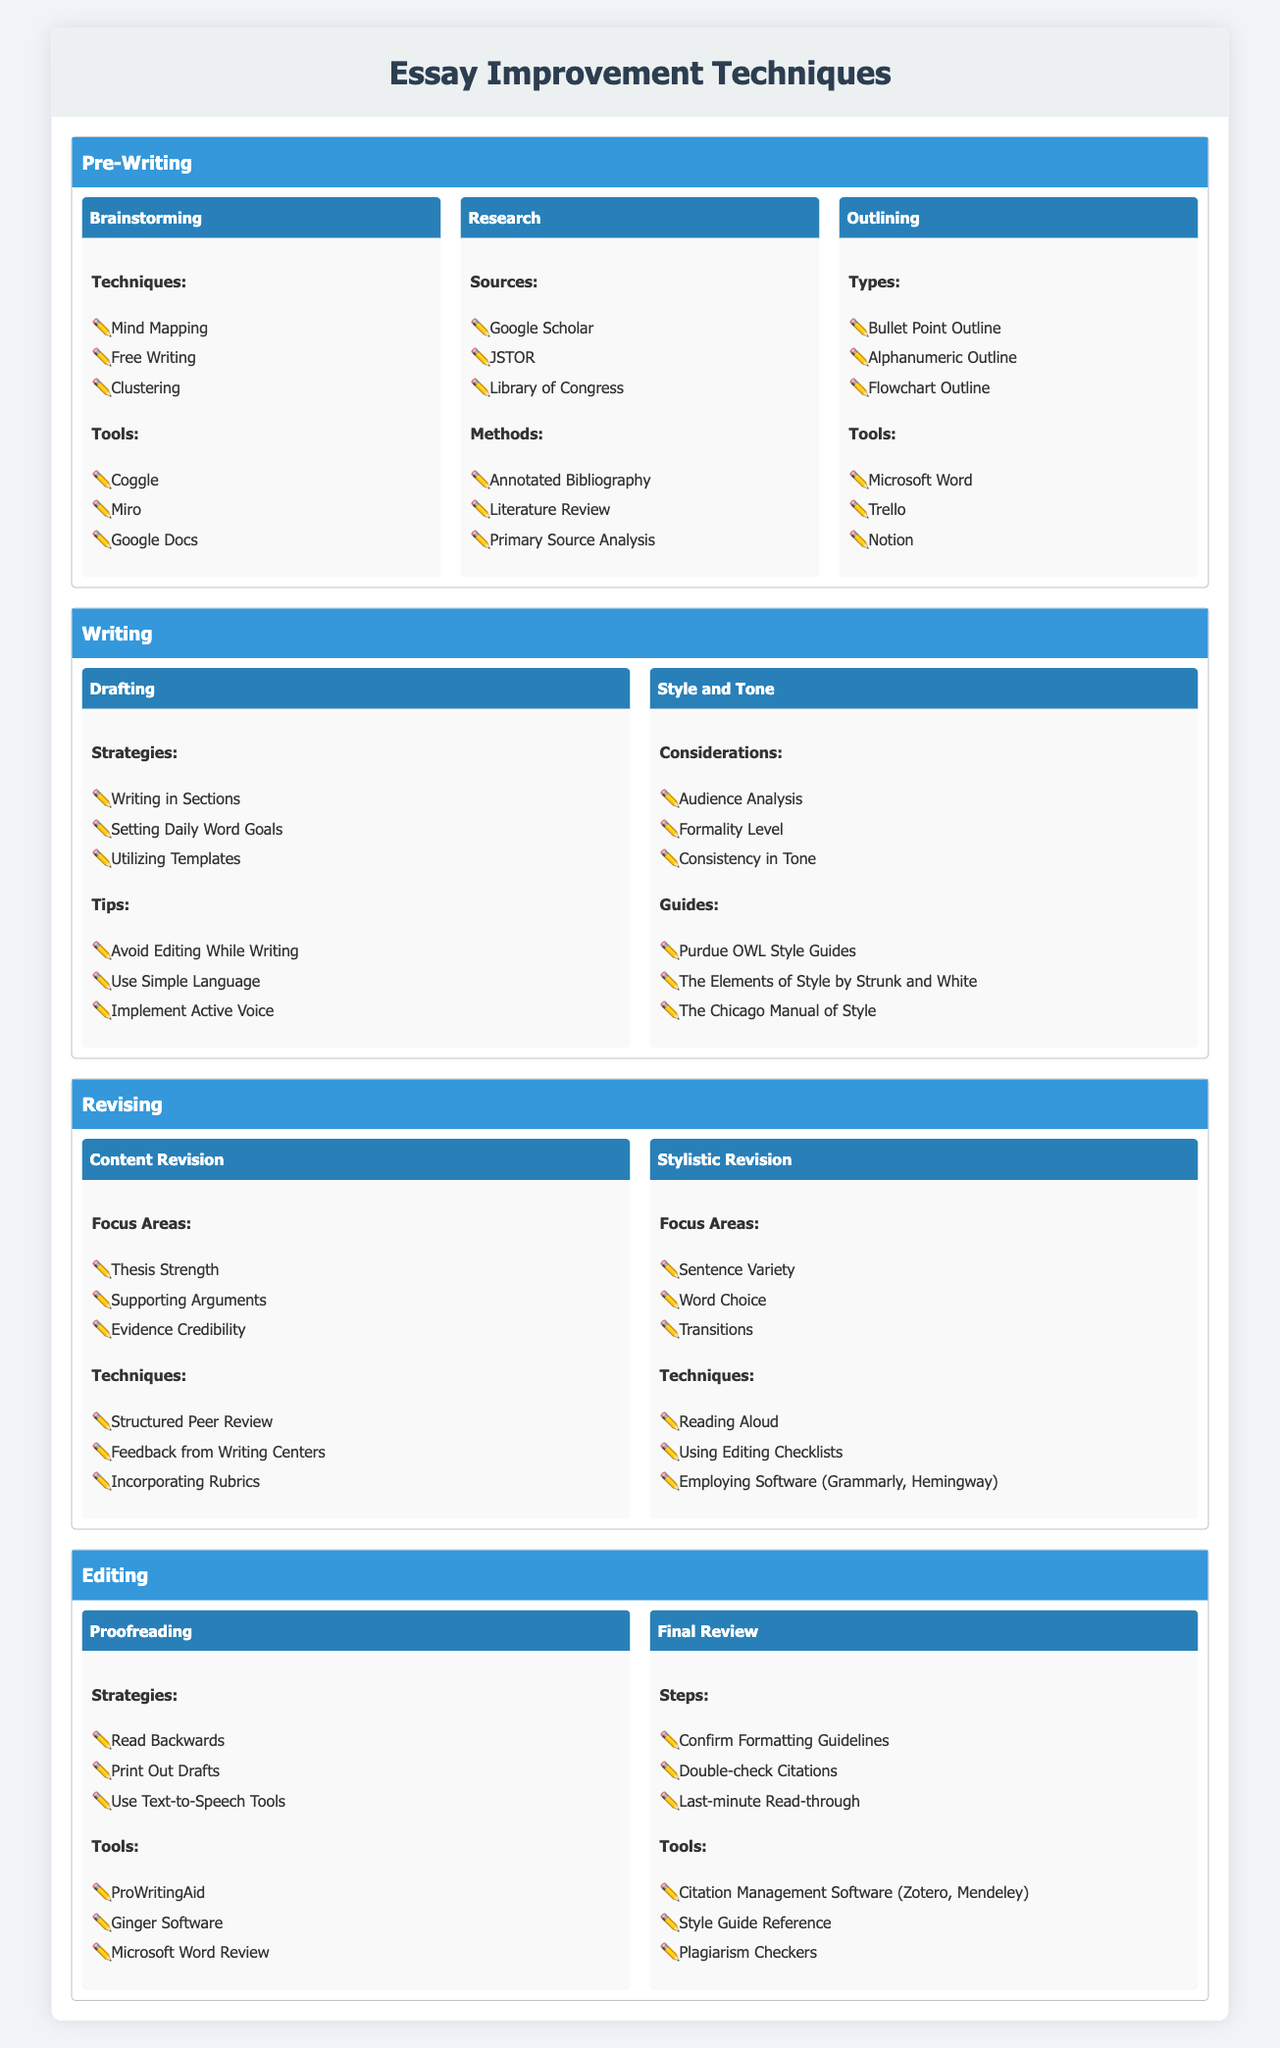What are the techniques listed under brainstorming in the pre-writing stage? The table lists three techniques under brainstorming: Mind Mapping, Free Writing, and Clustering. These are presented under the category of Brainstorming in the Pre-Writing section.
Answer: Mind Mapping, Free Writing, Clustering Which tools can be used for outlining? The tools for outlining are mentioned as Microsoft Word, Trello, and Notion, found in the Outlining subcategory of the Pre-Writing stage.
Answer: Microsoft Word, Trello, Notion Are there any considerations for style and tone in the writing stage? Yes, the table includes considerations for style and tone: Audience Analysis, Formality Level, and Consistency in Tone, found in the Style and Tone category under the Writing stage.
Answer: Yes How many strategies are listed under proofreading and what are they? There are three strategies for proofreading: Read Backwards, Print Out Drafts, and Use Text-to-Speech Tools. This information is gathered from the Proofreading subcategory in the Editing stage.
Answer: 3 strategies: Read Backwards, Print Out Drafts, Use Text-to-Speech Tools If a writer aims to enhance the strength of their thesis and improve supporting arguments, which revision focus areas should they consider? The writer should focus on "Thesis Strength" and "Supporting Arguments" as these are explicitly listed as focus areas under Content Revision in the Revising stage of the table.
Answer: Thesis Strength, Supporting Arguments What types of outlines are available and how many are listed? The table outlines three types of outlines: Bullet Point Outline, Alphanumeric Outline, and Flowchart Outline. By counting the listed types in the Outlining category, we find there are three different types.
Answer: 3 types: Bullet Point Outline, Alphanumeric Outline, Flowchart Outline Are there any tools mentioned for final review? Yes, the tools for final review include Citation Management Software (Zotero, Mendeley), Style Guide Reference, and Plagiarism Checkers, according to the Final Review section in the Editing stage.
Answer: Yes Which techniques are recommended for stylistic revision? The table mentions three techniques: Reading Aloud, Using Editing Checklists, and Employing Software (like Grammarly, Hemingway), found under the Stylistic Revision category in the Revising stage.
Answer: Reading Aloud, Using Editing Checklists, Employing Software (Grammarly, Hemingway) What are the total number of sources and methods listed under research? There are three sources (Google Scholar, JSTOR, Library of Congress) and three methods (Annotated Bibliography, Literature Review, Primary Source Analysis) listed under the Research category in the Pre-Writing stage, making a total of 6. The calculation is 3 (sources) + 3 (methods) = 6.
Answer: 6 total sources and methods 